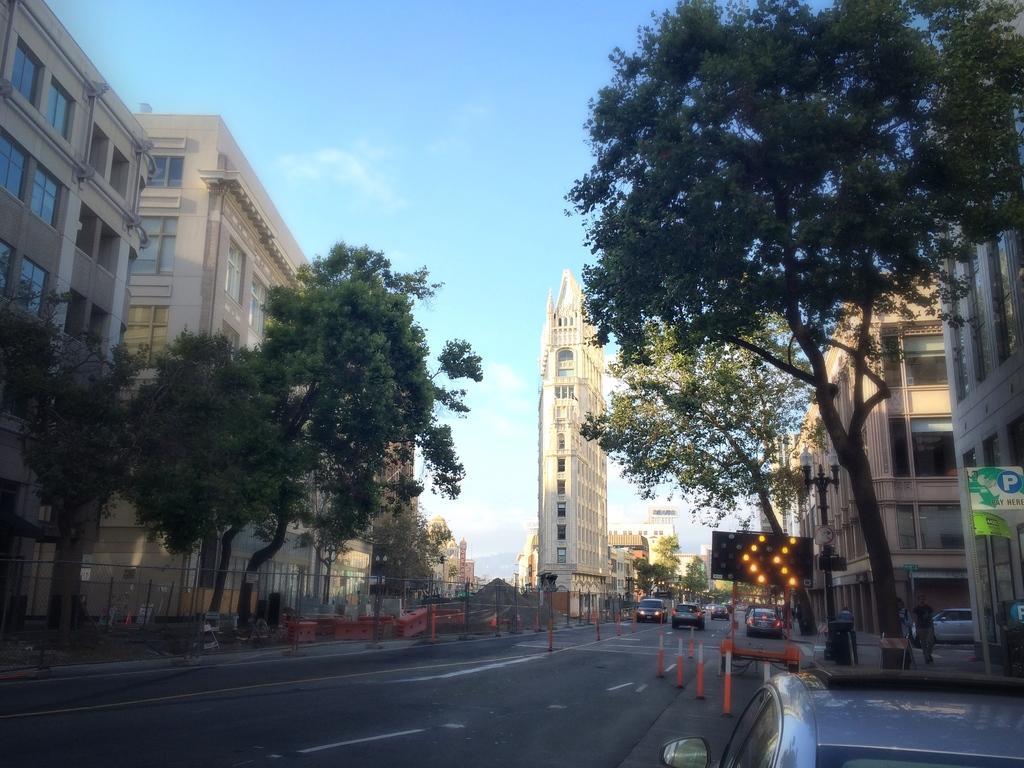Please provide a concise description of this image. In the picture I can see the buildings on the left side and the right side as well. I can see the cars on the road. There are trees on the side of the road. This is looking like a cathedral construction on the side of the road. I can see an LED direction display screen on the right side. There are three people walking on the side of the road. There are clouds in the sky. 